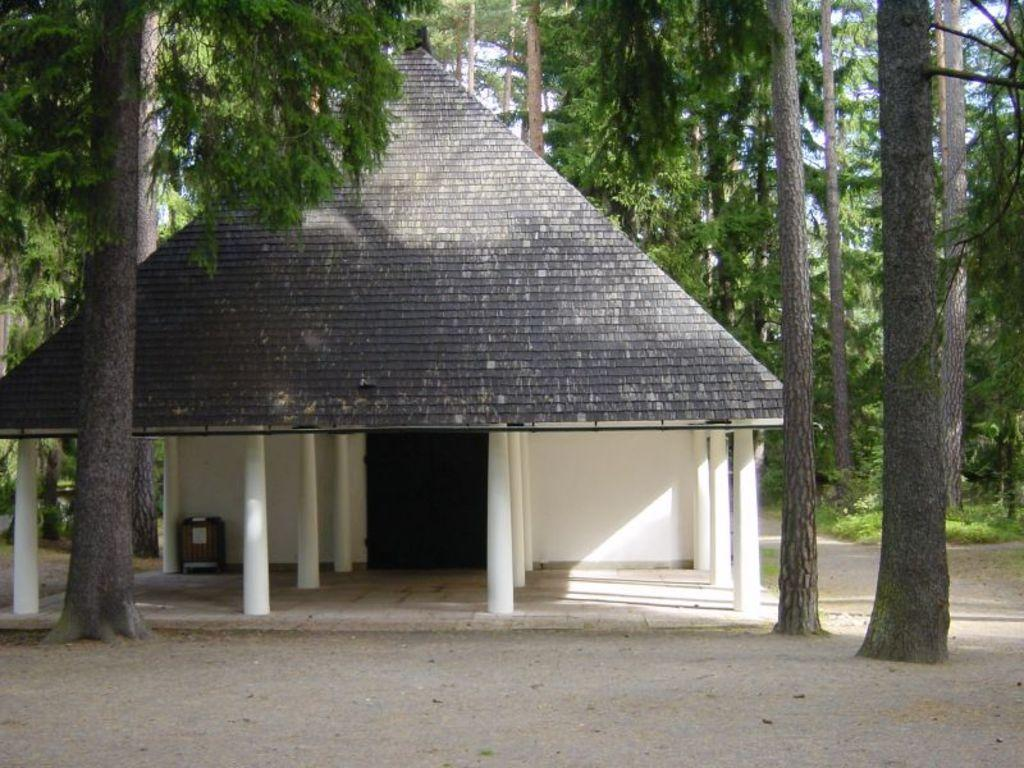What type of architectural feature can be seen in the image? There are pillars in the image. What type of structure is present in the image? There is a house in the image. What type of vegetation is visible in the image? There are many trees in the image. What type of bells can be seen hanging from the trees in the image? There are no bells present in the image; it features pillars, a house, and trees. How many eggs are visible in the image? There are no eggs present in the image. 